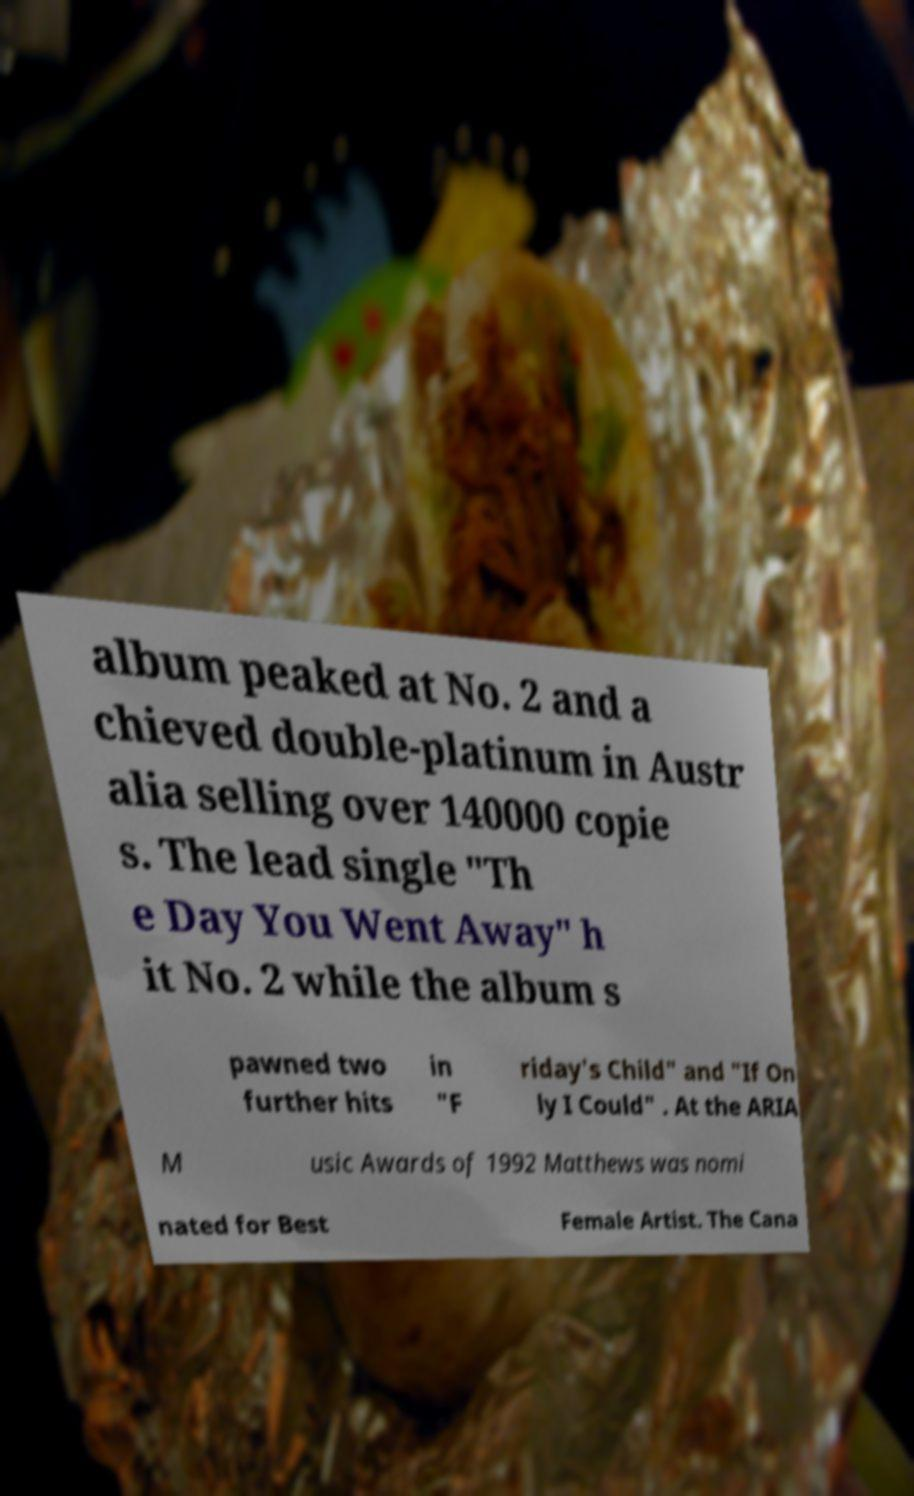What messages or text are displayed in this image? I need them in a readable, typed format. album peaked at No. 2 and a chieved double-platinum in Austr alia selling over 140000 copie s. The lead single "Th e Day You Went Away" h it No. 2 while the album s pawned two further hits in "F riday's Child" and "If On ly I Could" . At the ARIA M usic Awards of 1992 Matthews was nomi nated for Best Female Artist. The Cana 